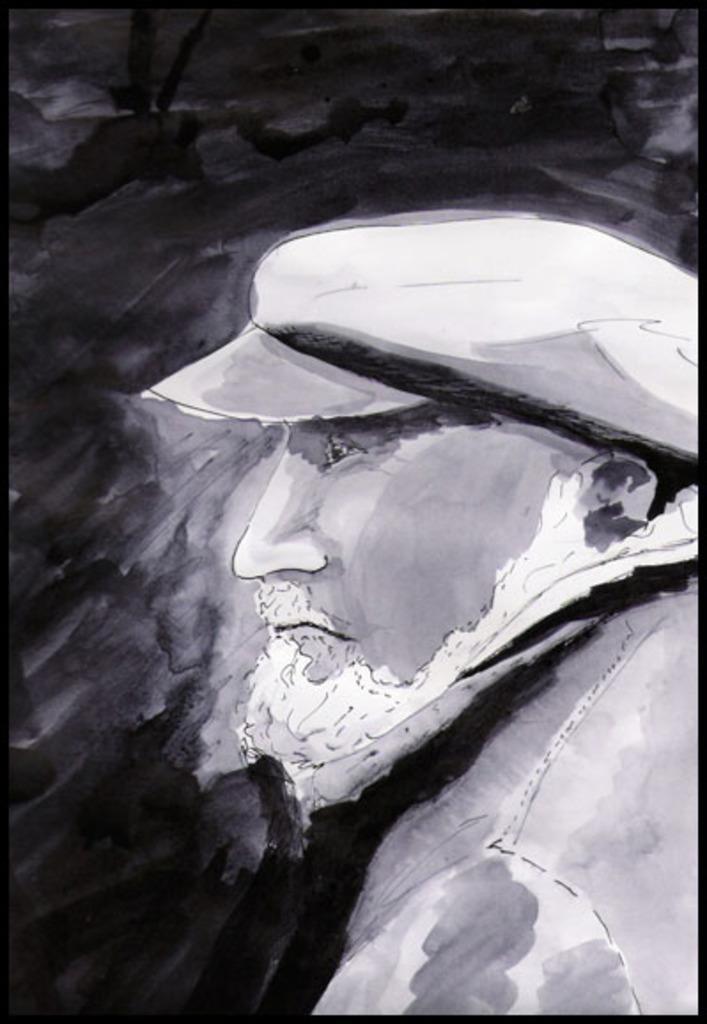Can you describe this image briefly? In the image we can see the painting, black and white in color. In the painting we can see a person wearing clothes and cap. 